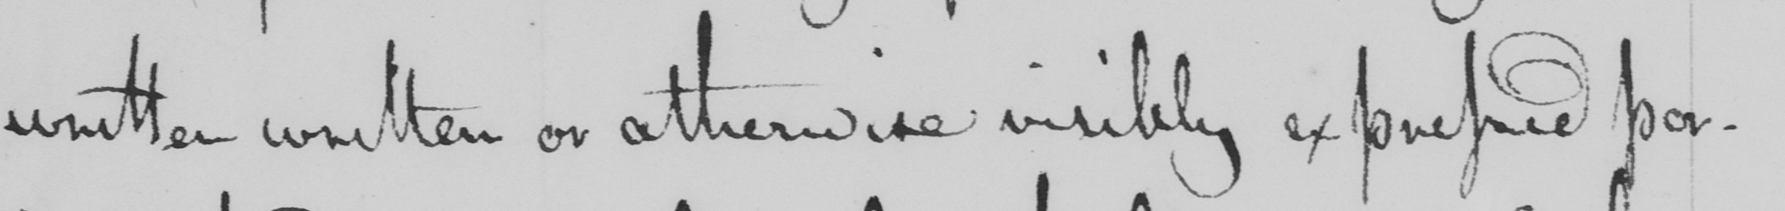What does this handwritten line say? written written or otherwise visibly expressed por- 